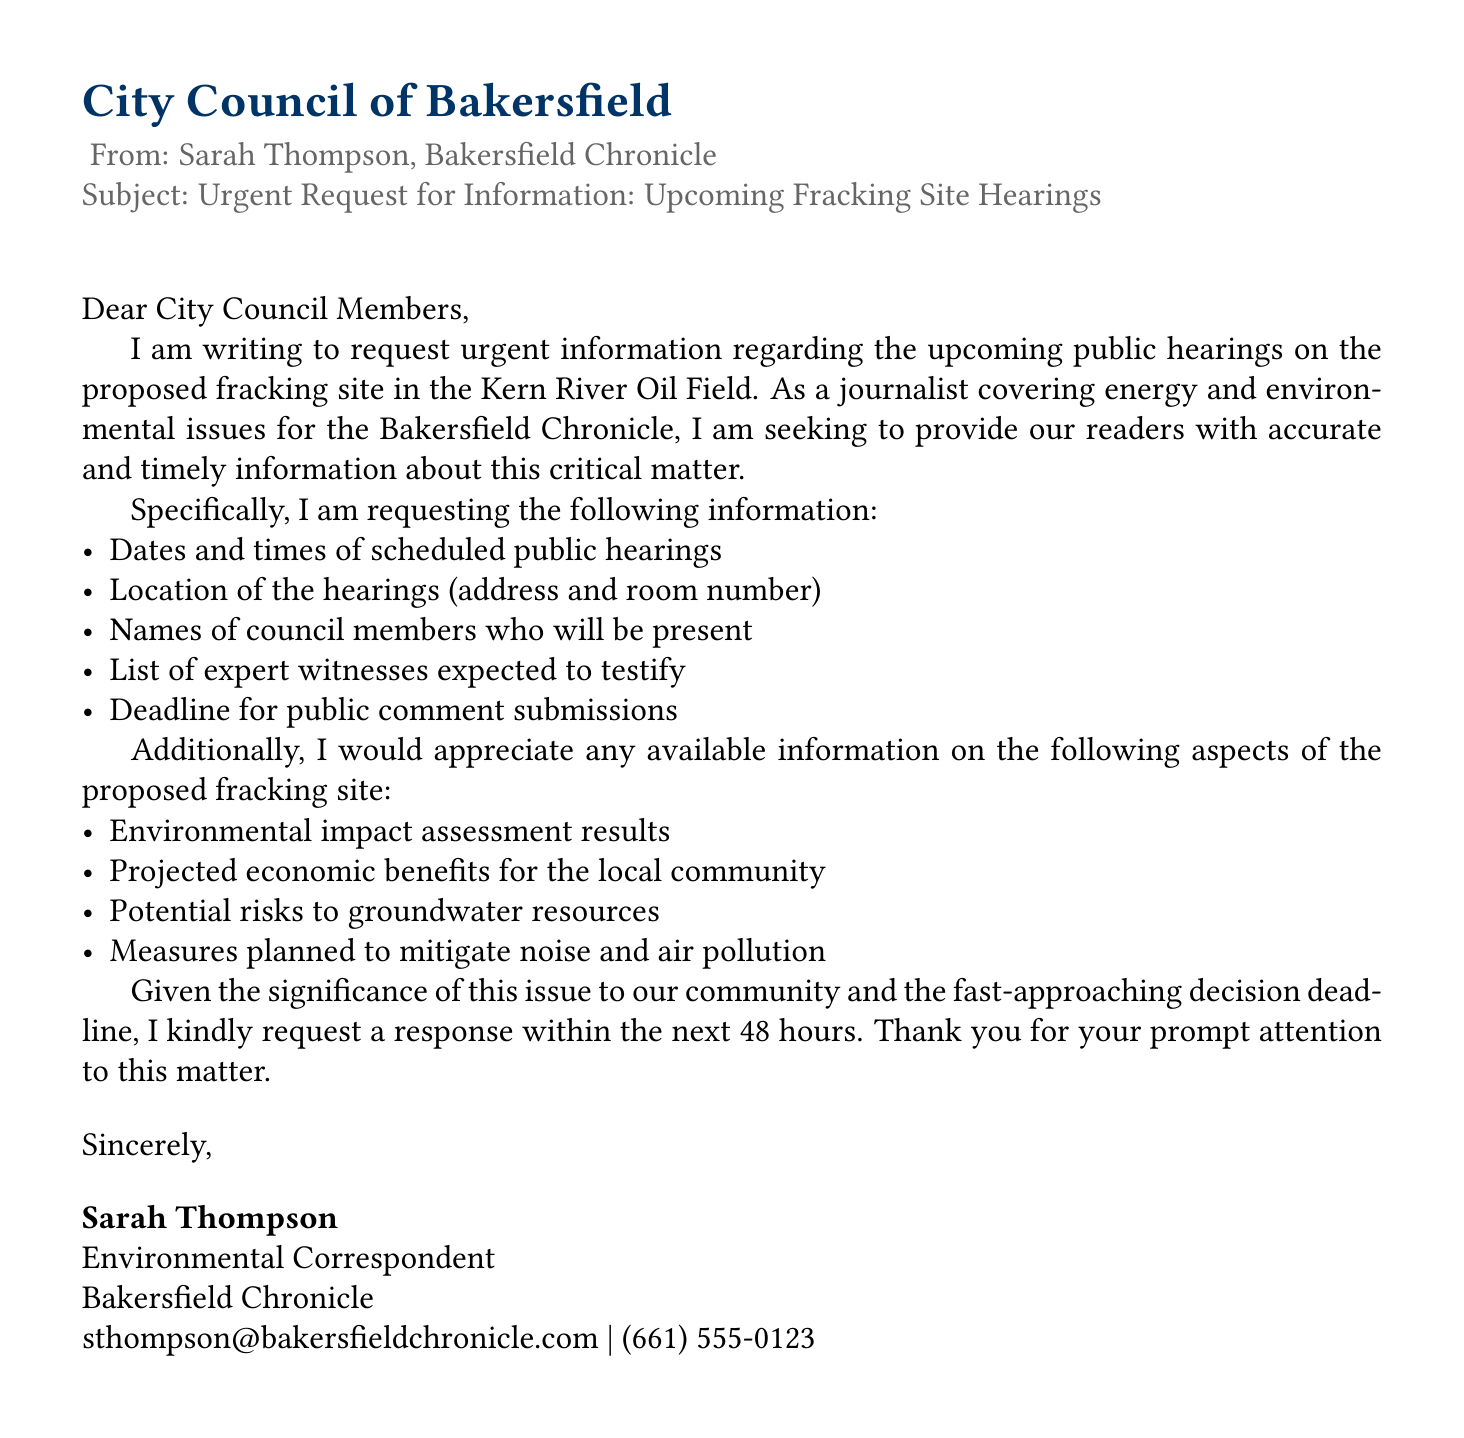What is the subject of the fax? The subject line of the fax clearly states the purpose of the communication.
Answer: Urgent Request for Information: Upcoming Fracking Site Hearings Who is the sender of the fax? The sender's name is mentioned at the bottom of the document.
Answer: Sarah Thompson What is the deadline for the city's response? The sender requests a response within a specific time frame mentioned in the closing paragraph.
Answer: 48 hours Where is the proposed fracking site located? The document specifies the geographical area related to the fracking site in the request.
Answer: Kern River Oil Field What type of assessment results is being requested? The sender asks for specific types of information related to environmental impacts.
Answer: Environmental impact assessment results What specific expert information is requested? The sender seeks a list of individuals who are expected to provide expert testimony during the hearings.
Answer: List of expert witnesses expected to testify What measures are being inquired about concerning pollution? The request includes inquiries about specific mitigation strategies regarding environmental pollution.
Answer: Measures planned to mitigate noise and air pollution How many items are listed in the initial information request? The document outlines a specific number of information requests in the first bullet list.
Answer: 5 items 